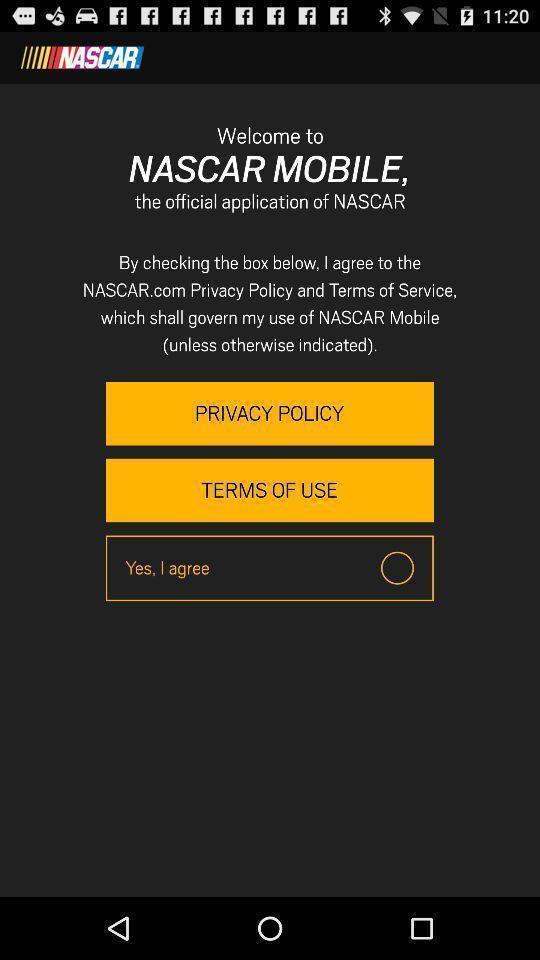Tell me what you see in this picture. Welcome page. 